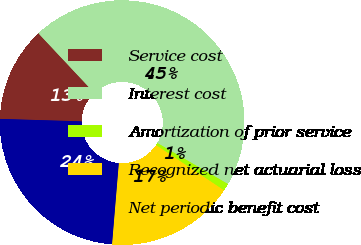Convert chart. <chart><loc_0><loc_0><loc_500><loc_500><pie_chart><fcel>Service cost<fcel>Interest cost<fcel>Amortization of prior service<fcel>Recognized net actuarial loss<fcel>Net periodic benefit cost<nl><fcel>12.54%<fcel>45.37%<fcel>0.97%<fcel>16.98%<fcel>24.15%<nl></chart> 